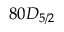<formula> <loc_0><loc_0><loc_500><loc_500>8 0 D _ { 5 / 2 }</formula> 